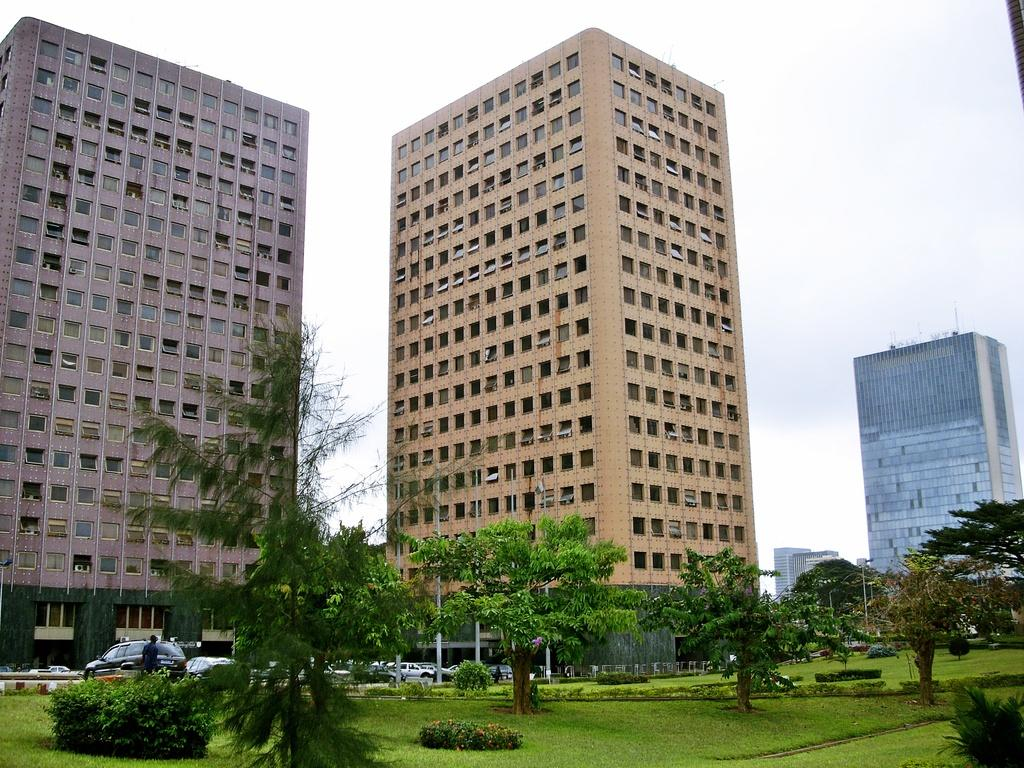What type of structures can be seen in the image? There are buildings in the image. What feature do the buildings have? The buildings have glass windows. What other elements can be seen in the image besides buildings? Trees, vehicles, and light-poles are present in the image. What is the color of the sky in the image? The sky is blue and white in color. How many women are walking their pets in the image? There are no women or pets present in the image. 